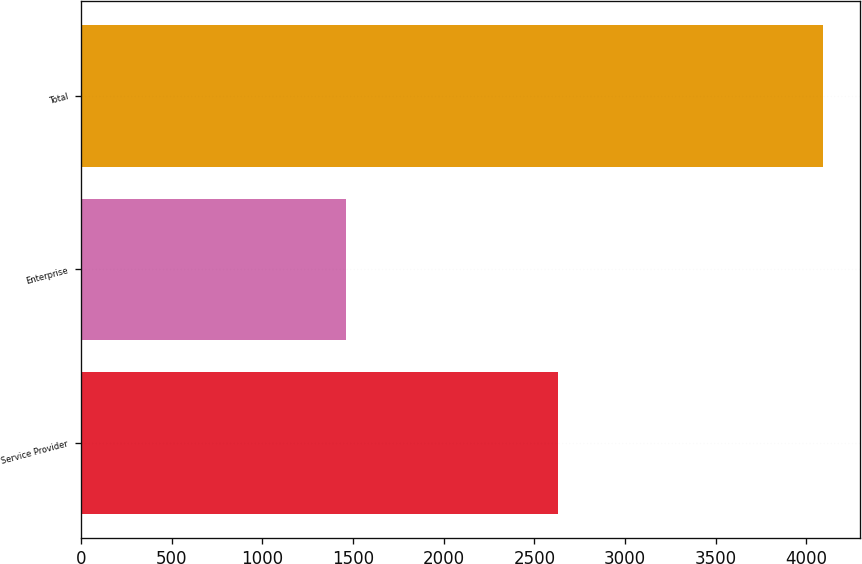Convert chart. <chart><loc_0><loc_0><loc_500><loc_500><bar_chart><fcel>Service Provider<fcel>Enterprise<fcel>Total<nl><fcel>2631.5<fcel>1461.8<fcel>4093.3<nl></chart> 